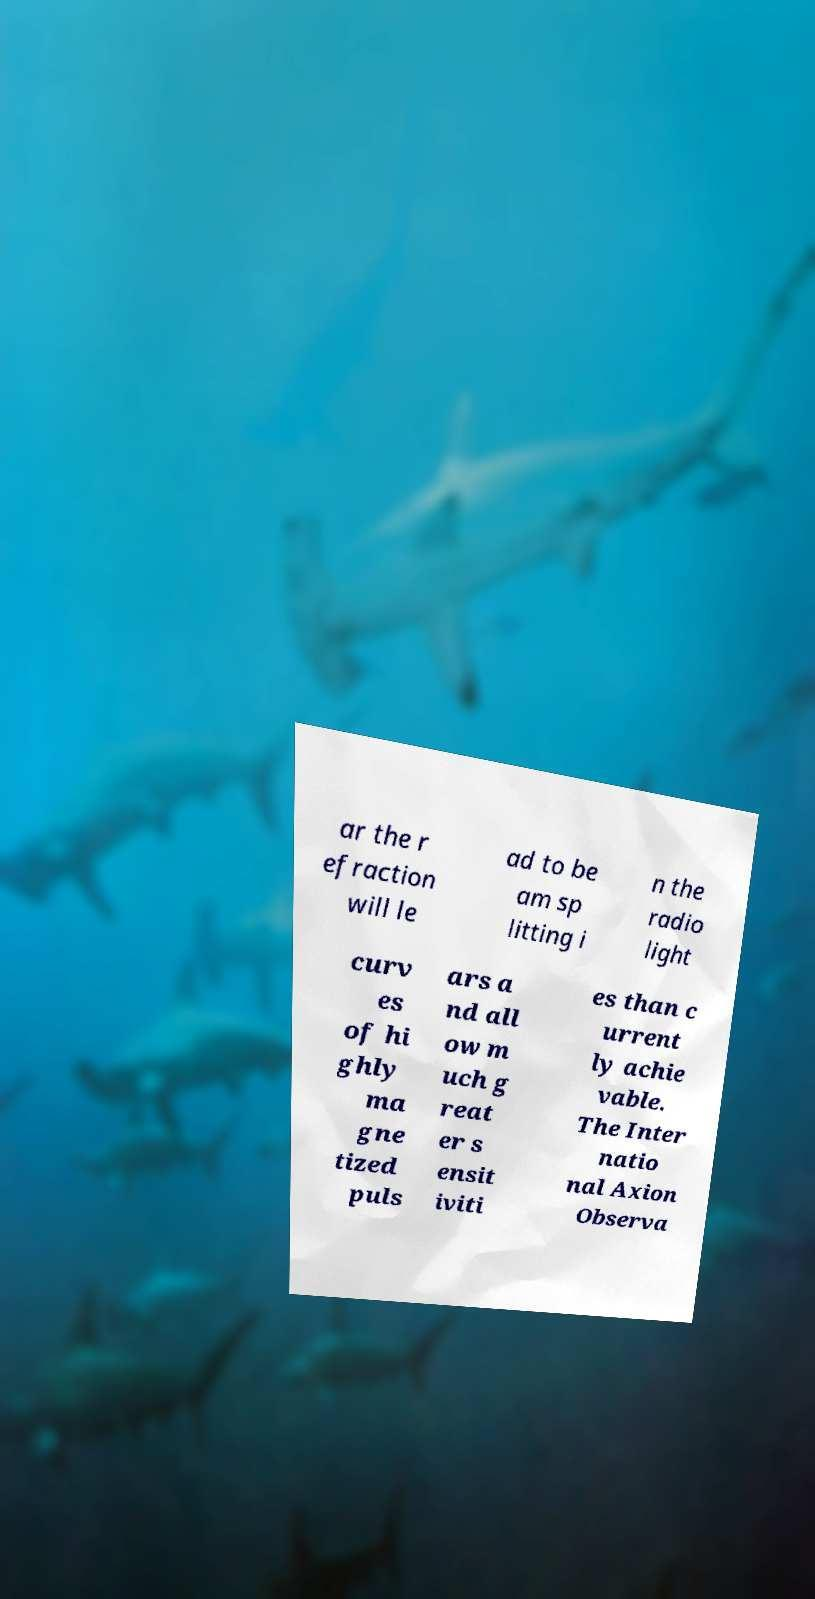Could you extract and type out the text from this image? ar the r efraction will le ad to be am sp litting i n the radio light curv es of hi ghly ma gne tized puls ars a nd all ow m uch g reat er s ensit iviti es than c urrent ly achie vable. The Inter natio nal Axion Observa 